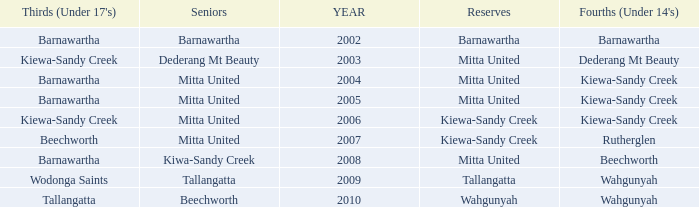Which seniors have a year before 2007, Fourths (Under 14's) of kiewa-sandy creek, and a Reserve of mitta united? Mitta United, Mitta United. 